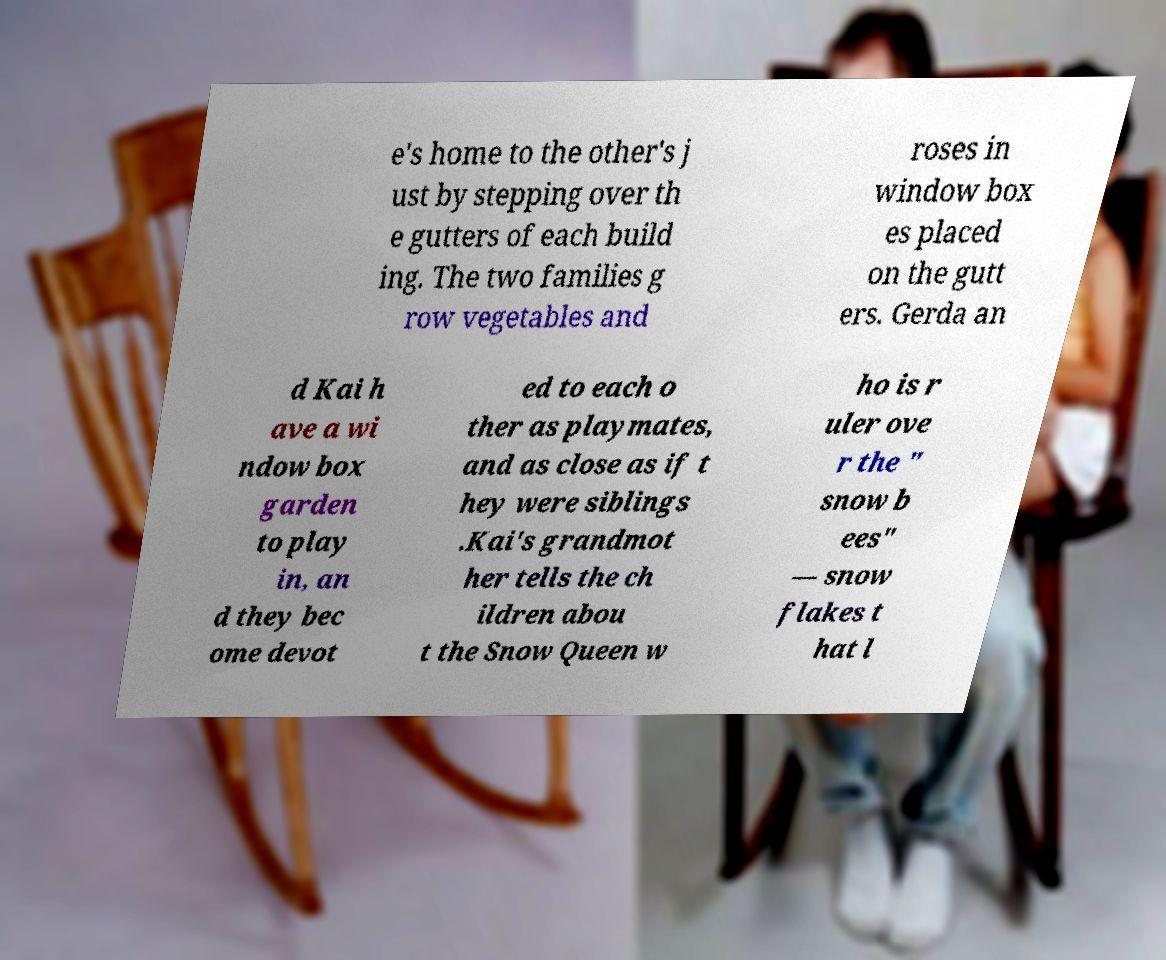I need the written content from this picture converted into text. Can you do that? e's home to the other's j ust by stepping over th e gutters of each build ing. The two families g row vegetables and roses in window box es placed on the gutt ers. Gerda an d Kai h ave a wi ndow box garden to play in, an d they bec ome devot ed to each o ther as playmates, and as close as if t hey were siblings .Kai's grandmot her tells the ch ildren abou t the Snow Queen w ho is r uler ove r the " snow b ees" — snow flakes t hat l 